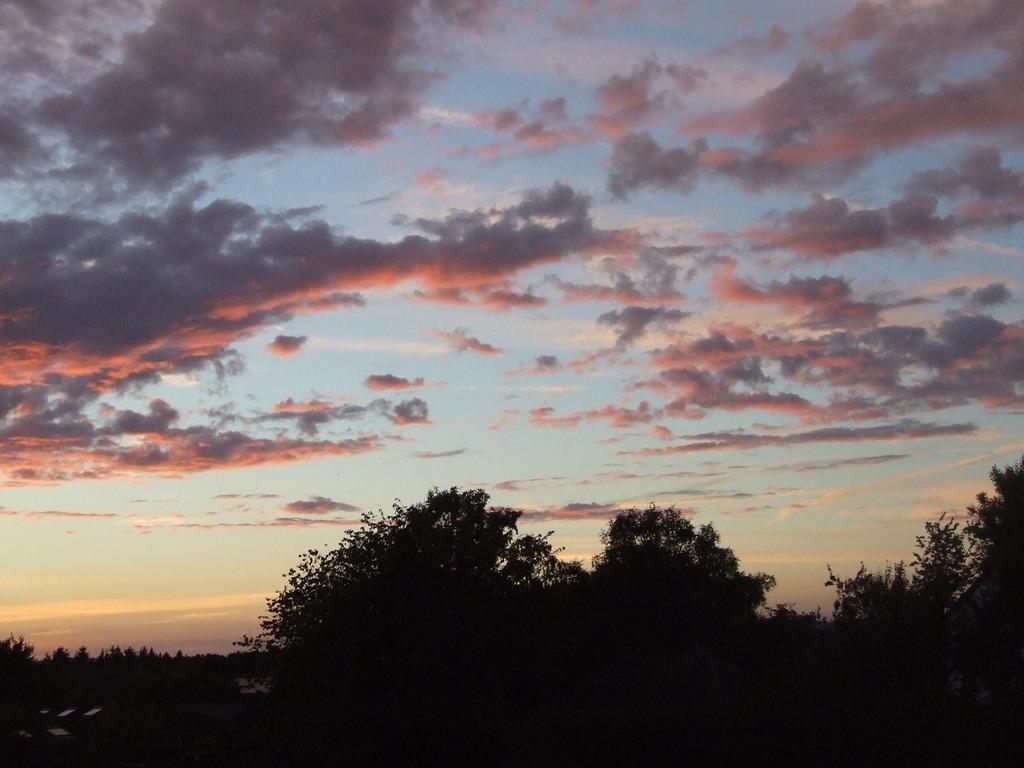Can you describe this image briefly? In this image I can see number of trees in the front. In the background I can see clouds and the sky. 